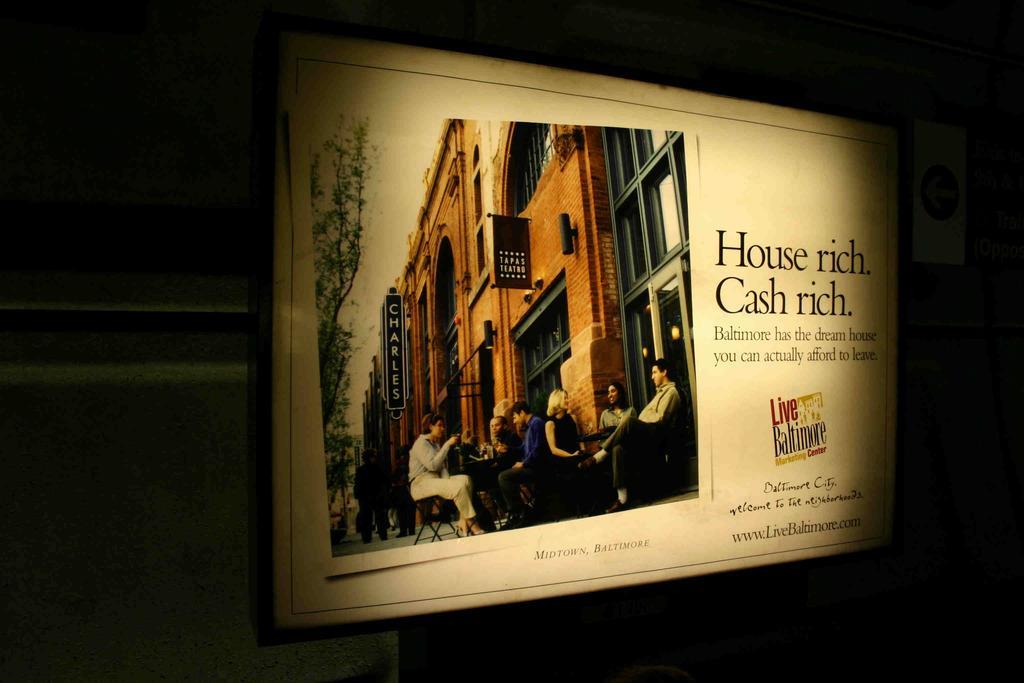How would you summarize this image in a sentence or two? In this image I can see a board. In the board I can see few buildings, windows, trees, boards and few people are standing and few people are sitting on chairs and something is written on the board. Background is in black color. 